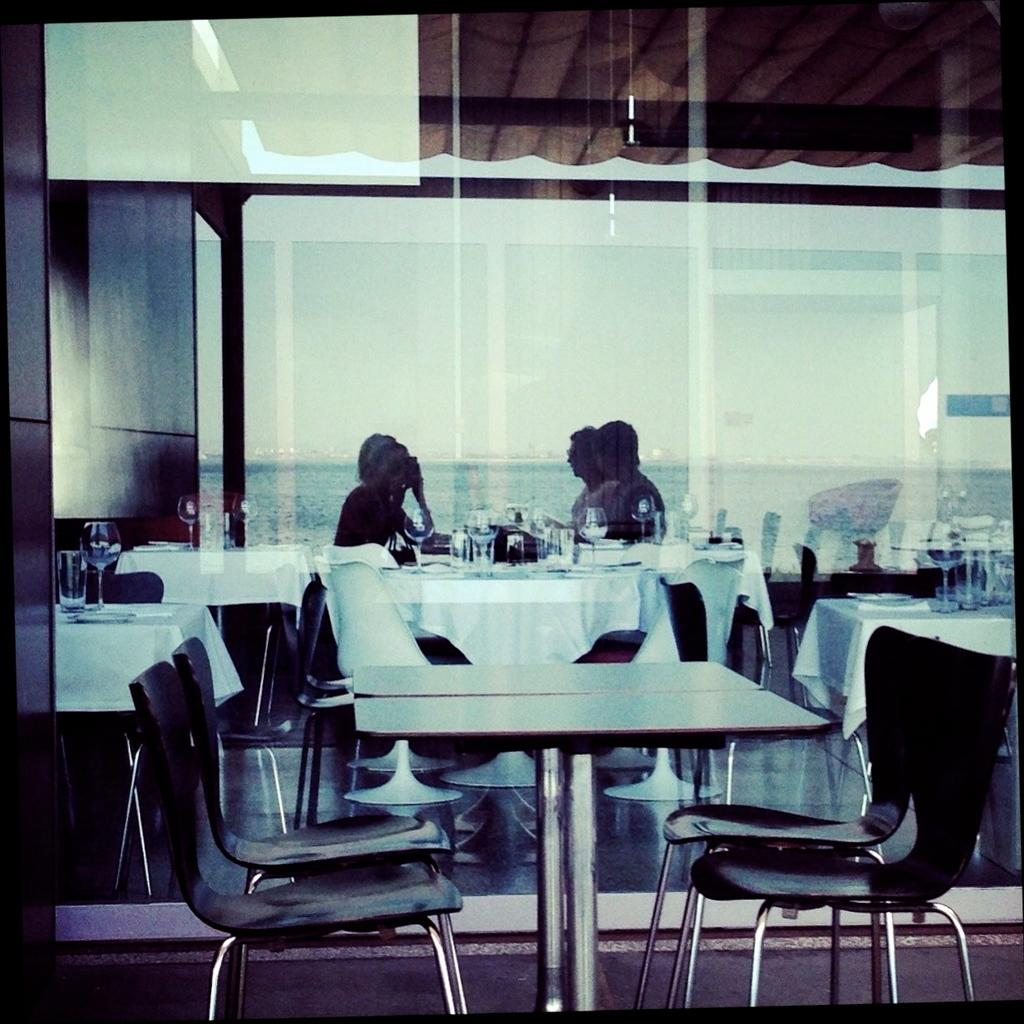What type of furniture is visible in the image? There are many tables and chairs in the image. Can you describe the people in the image? Four persons are sitting in the back of the image. What objects are on the table? There are glasses on the table. What architectural feature can be seen in the background of the image? There is a glass wall in the background of the image. What type of smoke can be seen coming from the spy's cigarette in the image? There is no spy or cigarette present in the image. 